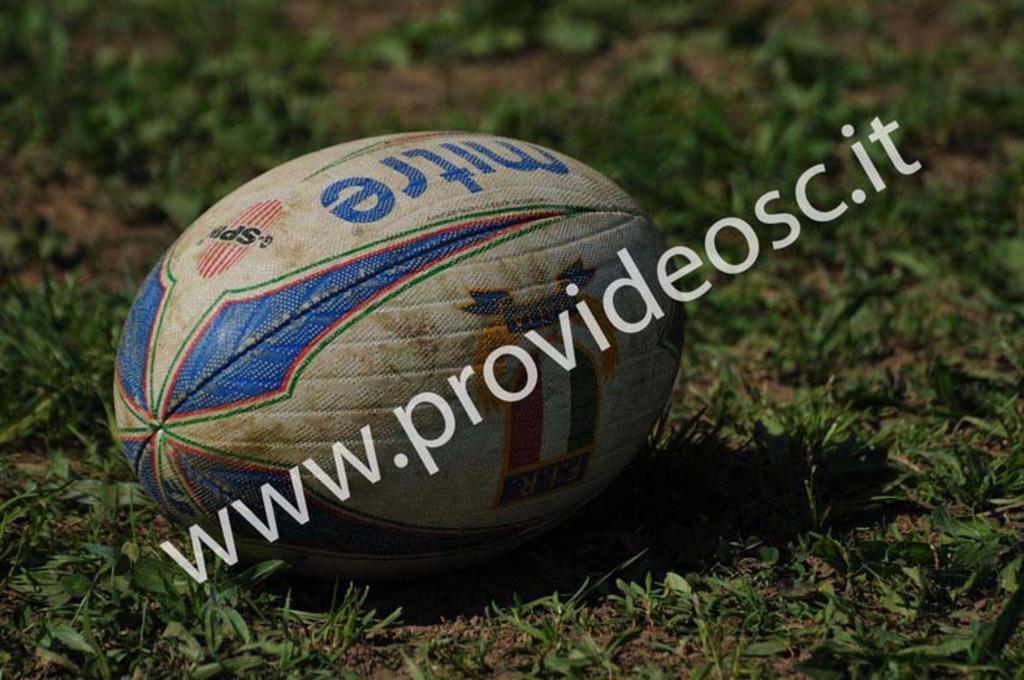Could you give a brief overview of what you see in this image? Where ball is present in the green grass. 